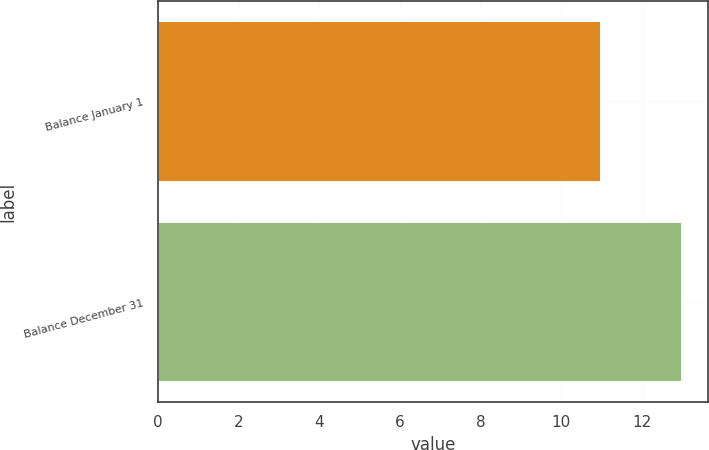<chart> <loc_0><loc_0><loc_500><loc_500><bar_chart><fcel>Balance January 1<fcel>Balance December 31<nl><fcel>11<fcel>13<nl></chart> 